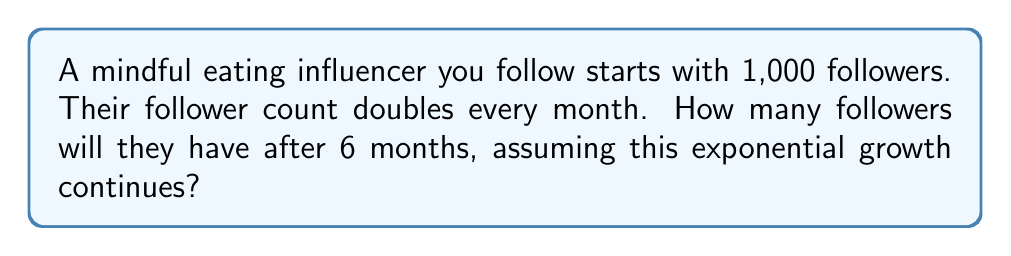Solve this math problem. Let's approach this step-by-step:

1) We start with 1,000 followers.
2) The growth is exponential, doubling every month.
3) We need to calculate this for 6 months.

The exponential growth can be represented by the formula:

$$ A = P(1+r)^n $$

Where:
A = Final amount
P = Initial principal balance
r = Growth rate (in this case, 100% or 1)
n = Number of time periods (in this case, 6 months)

For our problem:
P = 1,000
r = 1 (doubling means 100% increase)
n = 6

Let's substitute these values:

$$ A = 1000(1+1)^6 $$

Simplify:
$$ A = 1000(2)^6 $$

Calculate:
$$ A = 1000 * 64 = 64,000 $$

Therefore, after 6 months, the influencer will have 64,000 followers.
Answer: 64,000 followers 